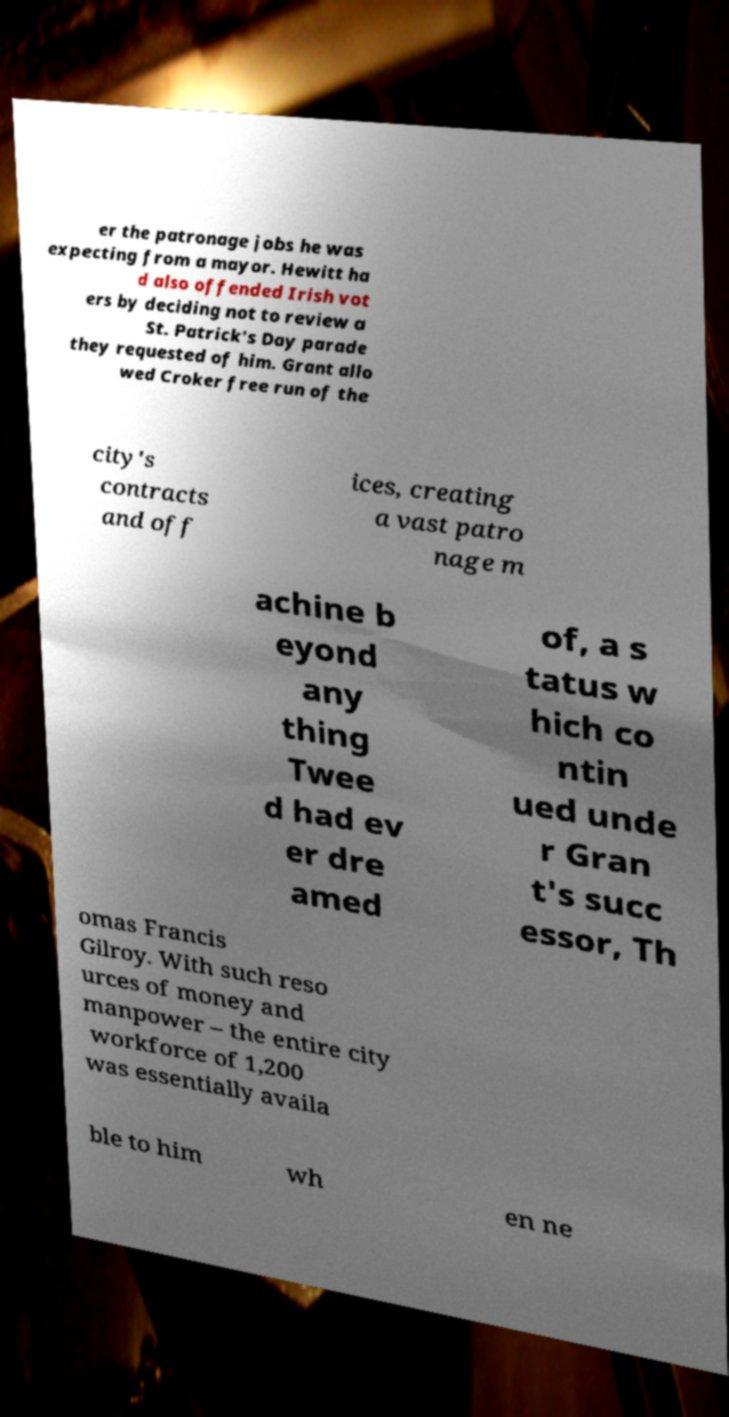Can you accurately transcribe the text from the provided image for me? er the patronage jobs he was expecting from a mayor. Hewitt ha d also offended Irish vot ers by deciding not to review a St. Patrick's Day parade they requested of him. Grant allo wed Croker free run of the city's contracts and off ices, creating a vast patro nage m achine b eyond any thing Twee d had ev er dre amed of, a s tatus w hich co ntin ued unde r Gran t's succ essor, Th omas Francis Gilroy. With such reso urces of money and manpower – the entire city workforce of 1,200 was essentially availa ble to him wh en ne 